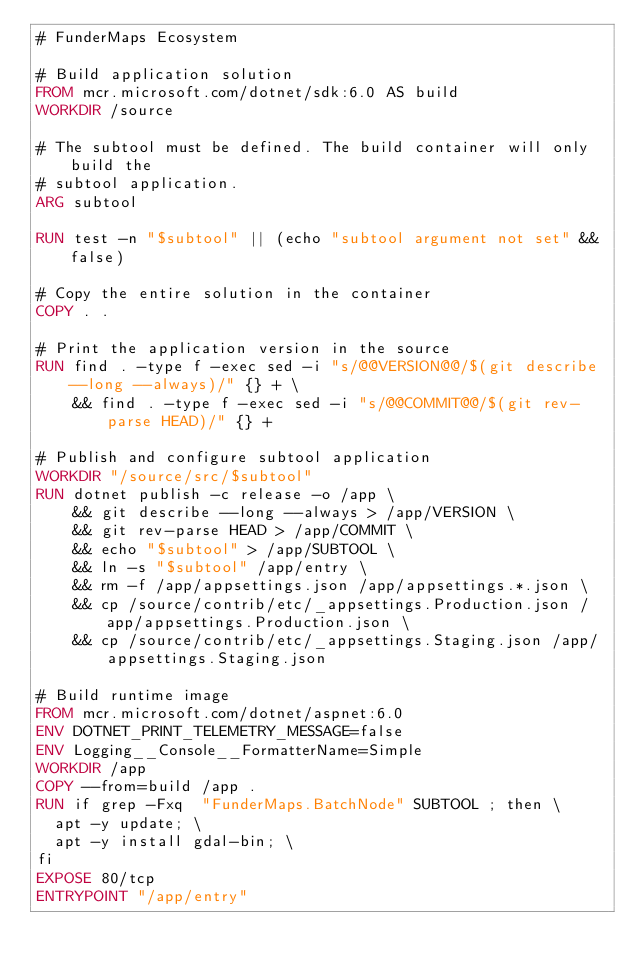<code> <loc_0><loc_0><loc_500><loc_500><_Dockerfile_># FunderMaps Ecosystem

# Build application solution
FROM mcr.microsoft.com/dotnet/sdk:6.0 AS build
WORKDIR /source

# The subtool must be defined. The build container will only build the
# subtool application.
ARG subtool

RUN test -n "$subtool" || (echo "subtool argument not set" && false)

# Copy the entire solution in the container
COPY . .

# Print the application version in the source
RUN find . -type f -exec sed -i "s/@@VERSION@@/$(git describe --long --always)/" {} + \
    && find . -type f -exec sed -i "s/@@COMMIT@@/$(git rev-parse HEAD)/" {} +

# Publish and configure subtool application
WORKDIR "/source/src/$subtool"
RUN dotnet publish -c release -o /app \
    && git describe --long --always > /app/VERSION \
    && git rev-parse HEAD > /app/COMMIT \
    && echo "$subtool" > /app/SUBTOOL \
    && ln -s "$subtool" /app/entry \
    && rm -f /app/appsettings.json /app/appsettings.*.json \
    && cp /source/contrib/etc/_appsettings.Production.json /app/appsettings.Production.json \
    && cp /source/contrib/etc/_appsettings.Staging.json /app/appsettings.Staging.json

# Build runtime image
FROM mcr.microsoft.com/dotnet/aspnet:6.0
ENV DOTNET_PRINT_TELEMETRY_MESSAGE=false
ENV Logging__Console__FormatterName=Simple
WORKDIR /app
COPY --from=build /app .
RUN if grep -Fxq  "FunderMaps.BatchNode" SUBTOOL ; then \
  apt -y update; \
  apt -y install gdal-bin; \
fi
EXPOSE 80/tcp
ENTRYPOINT "/app/entry"
</code> 